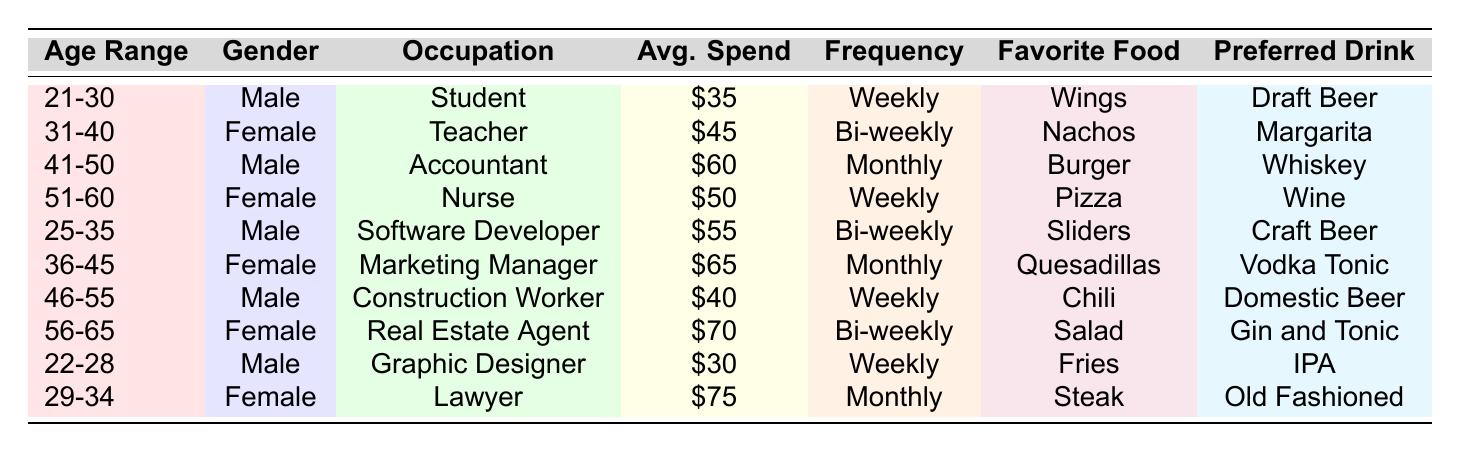What is the average spend of female attendees? Looking at the table, the average spends of female attendees are $45, $50, $65, and $75. Adding these values gives $45 + $50 + $65 + $75 = $235. There are 4 female attendees, so the average is $235 / 4 = $58.75.
Answer: $58.75 How many male attendees have a preferred drink of beer? Reviewing the table, the male attendees with a preferred drink of beer are listed as those who chose Draft Beer, Domestic Beer, and Craft Beer. That's a total of 3 male attendees.
Answer: 3 What is the frequency of attendance for the 36-45 age group? The table shows that the 36-45 age group, represented by a Marketing Manager, has a frequency of attendance listed as Monthly.
Answer: Monthly Is there a female attendee who prefers wine? Looking through the table, yes, there is a female attendee (the Nurse) whose preferred drink is listed as Wine.
Answer: Yes Who spends the most on average among the attendees? Examining all the average spends in the table, we see $75 (the Lawyer) is the highest spend.
Answer: $75 What is the difference between the average spend of the youngest and oldest attendees? The youngest attendee (22-28 age range) spends $30, while the oldest (56-65 age range) spends $70. The difference is $70 - $30 = $40.
Answer: $40 What is the favorite food of the attendee with the highest average spend? The attendee with the highest average spend is the Lawyer who spends $75, and their favorite food is Steak.
Answer: Steak How many attendees prefer nachos or sliders? From the table, one attendee (the Teacher) prefers Nachos and another (the Software Developer) prefers Sliders, giving a total of 2 attendees.
Answer: 2 Is the average spend of the 51-60 age group higher than that of the 31-40 age group? The average spend for the 51-60 age group is $50, while for the 31-40 age group it is $45. Comparing these, $50 is higher than $45.
Answer: Yes Which gender has the highest average spend overall? The average spends by gender are $35, $60, $40 for male, and $45, $50, $65, $75 for female. Calculating the averages shows that females (average $58.75) have a higher average spend than males (average $45).
Answer: Female 